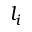<formula> <loc_0><loc_0><loc_500><loc_500>l _ { i }</formula> 